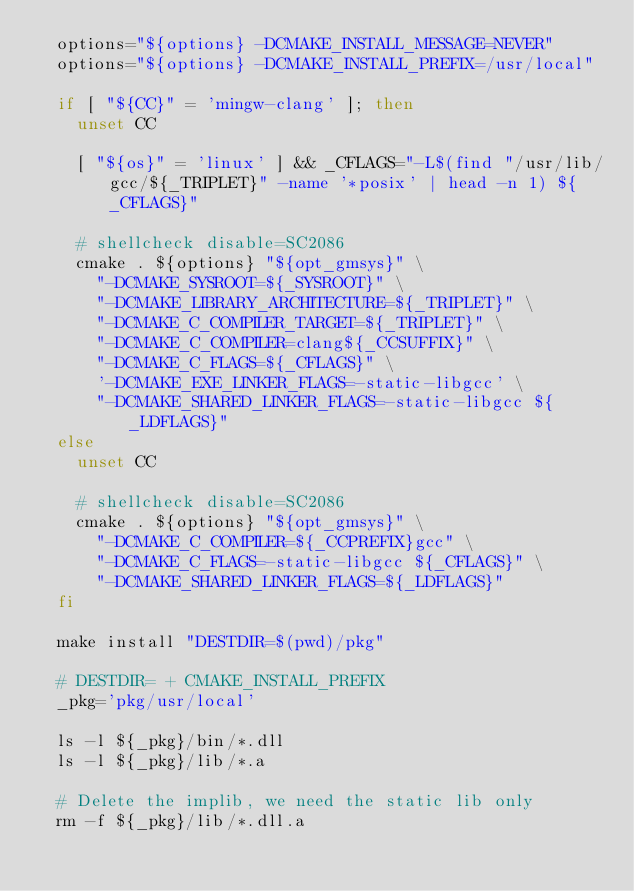<code> <loc_0><loc_0><loc_500><loc_500><_Bash_>  options="${options} -DCMAKE_INSTALL_MESSAGE=NEVER"
  options="${options} -DCMAKE_INSTALL_PREFIX=/usr/local"

  if [ "${CC}" = 'mingw-clang' ]; then
    unset CC

    [ "${os}" = 'linux' ] && _CFLAGS="-L$(find "/usr/lib/gcc/${_TRIPLET}" -name '*posix' | head -n 1) ${_CFLAGS}"

    # shellcheck disable=SC2086
    cmake . ${options} "${opt_gmsys}" \
      "-DCMAKE_SYSROOT=${_SYSROOT}" \
      "-DCMAKE_LIBRARY_ARCHITECTURE=${_TRIPLET}" \
      "-DCMAKE_C_COMPILER_TARGET=${_TRIPLET}" \
      "-DCMAKE_C_COMPILER=clang${_CCSUFFIX}" \
      "-DCMAKE_C_FLAGS=${_CFLAGS}" \
      '-DCMAKE_EXE_LINKER_FLAGS=-static-libgcc' \
      "-DCMAKE_SHARED_LINKER_FLAGS=-static-libgcc ${_LDFLAGS}"
  else
    unset CC

    # shellcheck disable=SC2086
    cmake . ${options} "${opt_gmsys}" \
      "-DCMAKE_C_COMPILER=${_CCPREFIX}gcc" \
      "-DCMAKE_C_FLAGS=-static-libgcc ${_CFLAGS}" \
      "-DCMAKE_SHARED_LINKER_FLAGS=${_LDFLAGS}"
  fi

  make install "DESTDIR=$(pwd)/pkg"

  # DESTDIR= + CMAKE_INSTALL_PREFIX
  _pkg='pkg/usr/local'

  ls -l ${_pkg}/bin/*.dll
  ls -l ${_pkg}/lib/*.a

  # Delete the implib, we need the static lib only
  rm -f ${_pkg}/lib/*.dll.a</code> 